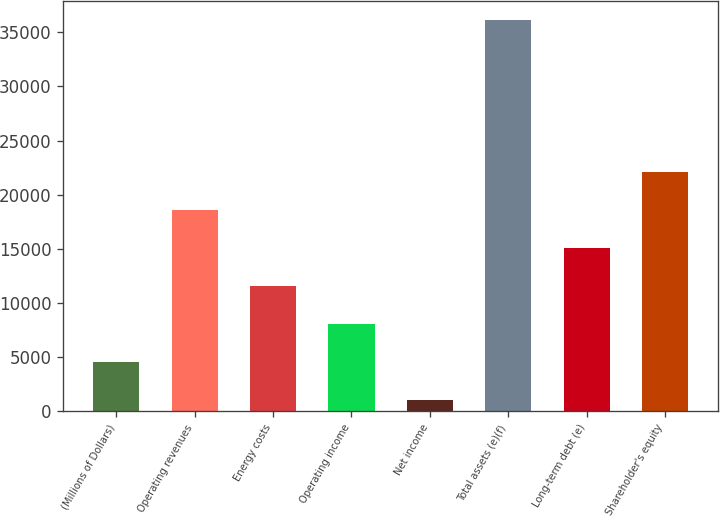Convert chart to OTSL. <chart><loc_0><loc_0><loc_500><loc_500><bar_chart><fcel>(Millions of Dollars)<fcel>Operating revenues<fcel>Energy costs<fcel>Operating income<fcel>Net income<fcel>Total assets (e)(f)<fcel>Long-term debt (e)<fcel>Shareholder's equity<nl><fcel>4527.5<fcel>18557.5<fcel>11542.5<fcel>8035<fcel>1020<fcel>36095<fcel>15050<fcel>22065<nl></chart> 